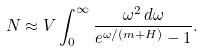<formula> <loc_0><loc_0><loc_500><loc_500>N \approx V \int _ { 0 } ^ { \infty } \frac { \omega ^ { 2 } \, d \omega } { e ^ { \omega / ( m + H ) } - 1 } .</formula> 